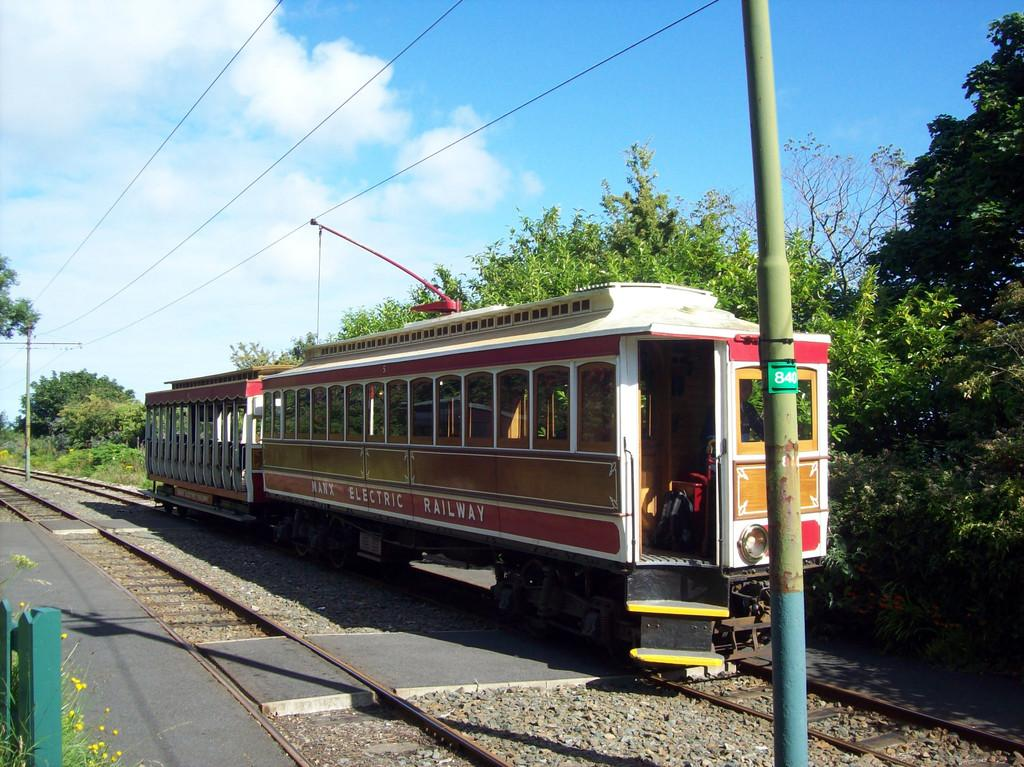What is the main feature of the image? There is a railway track in the image. What is traveling along the railway track? There is a train in the image. What else can be seen near the railway track? There is a pole and trees in the image. What is visible in the background of the image? There is sky visible in the image. Is there any vegetation other than trees in the image? Yes, there is a plant in the image. What type of thread is being used to hold the train together in the image? There is no thread visible in the image, and the train is not being held together by any thread. 